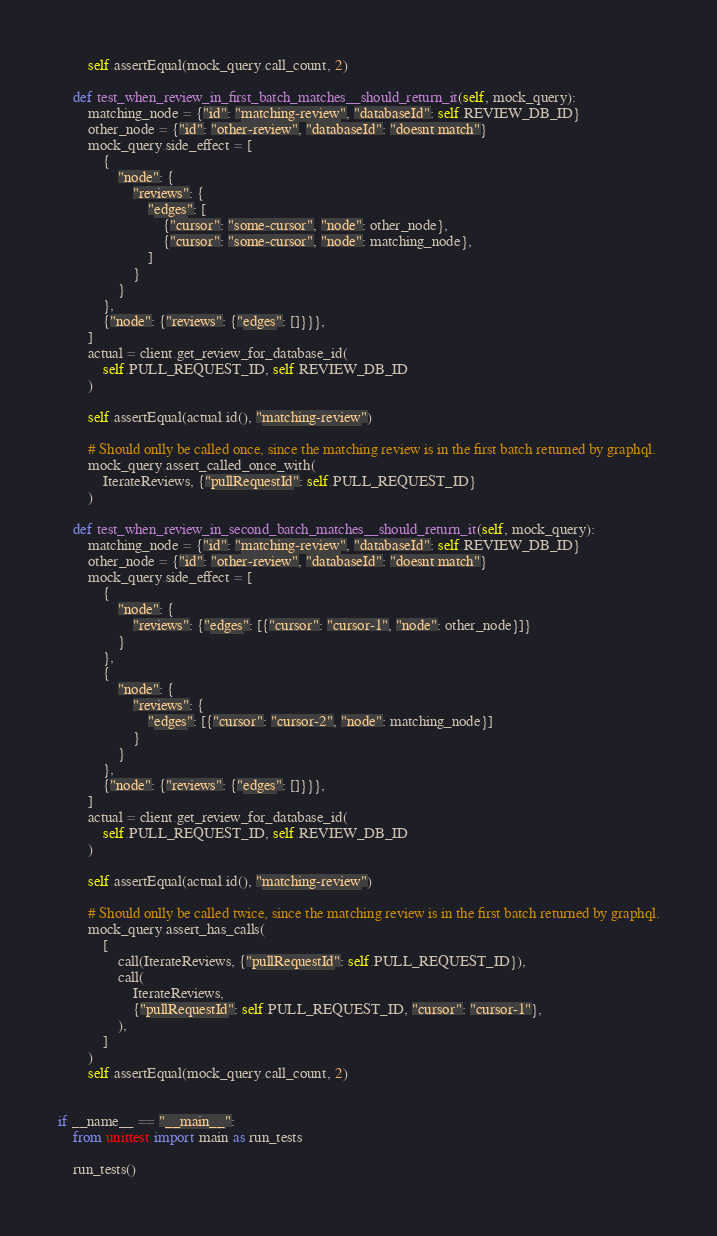<code> <loc_0><loc_0><loc_500><loc_500><_Python_>        self.assertEqual(mock_query.call_count, 2)

    def test_when_review_in_first_batch_matches__should_return_it(self, mock_query):
        matching_node = {"id": "matching-review", "databaseId": self.REVIEW_DB_ID}
        other_node = {"id": "other-review", "databaseId": "doesnt match"}
        mock_query.side_effect = [
            {
                "node": {
                    "reviews": {
                        "edges": [
                            {"cursor": "some-cursor", "node": other_node},
                            {"cursor": "some-cursor", "node": matching_node},
                        ]
                    }
                }
            },
            {"node": {"reviews": {"edges": []}}},
        ]
        actual = client.get_review_for_database_id(
            self.PULL_REQUEST_ID, self.REVIEW_DB_ID
        )

        self.assertEqual(actual.id(), "matching-review")

        # Should onlly be called once, since the matching review is in the first batch returned by graphql.
        mock_query.assert_called_once_with(
            IterateReviews, {"pullRequestId": self.PULL_REQUEST_ID}
        )

    def test_when_review_in_second_batch_matches__should_return_it(self, mock_query):
        matching_node = {"id": "matching-review", "databaseId": self.REVIEW_DB_ID}
        other_node = {"id": "other-review", "databaseId": "doesnt match"}
        mock_query.side_effect = [
            {
                "node": {
                    "reviews": {"edges": [{"cursor": "cursor-1", "node": other_node}]}
                }
            },
            {
                "node": {
                    "reviews": {
                        "edges": [{"cursor": "cursor-2", "node": matching_node}]
                    }
                }
            },
            {"node": {"reviews": {"edges": []}}},
        ]
        actual = client.get_review_for_database_id(
            self.PULL_REQUEST_ID, self.REVIEW_DB_ID
        )

        self.assertEqual(actual.id(), "matching-review")

        # Should onlly be called twice, since the matching review is in the first batch returned by graphql.
        mock_query.assert_has_calls(
            [
                call(IterateReviews, {"pullRequestId": self.PULL_REQUEST_ID}),
                call(
                    IterateReviews,
                    {"pullRequestId": self.PULL_REQUEST_ID, "cursor": "cursor-1"},
                ),
            ]
        )
        self.assertEqual(mock_query.call_count, 2)


if __name__ == "__main__":
    from unittest import main as run_tests

    run_tests()
</code> 